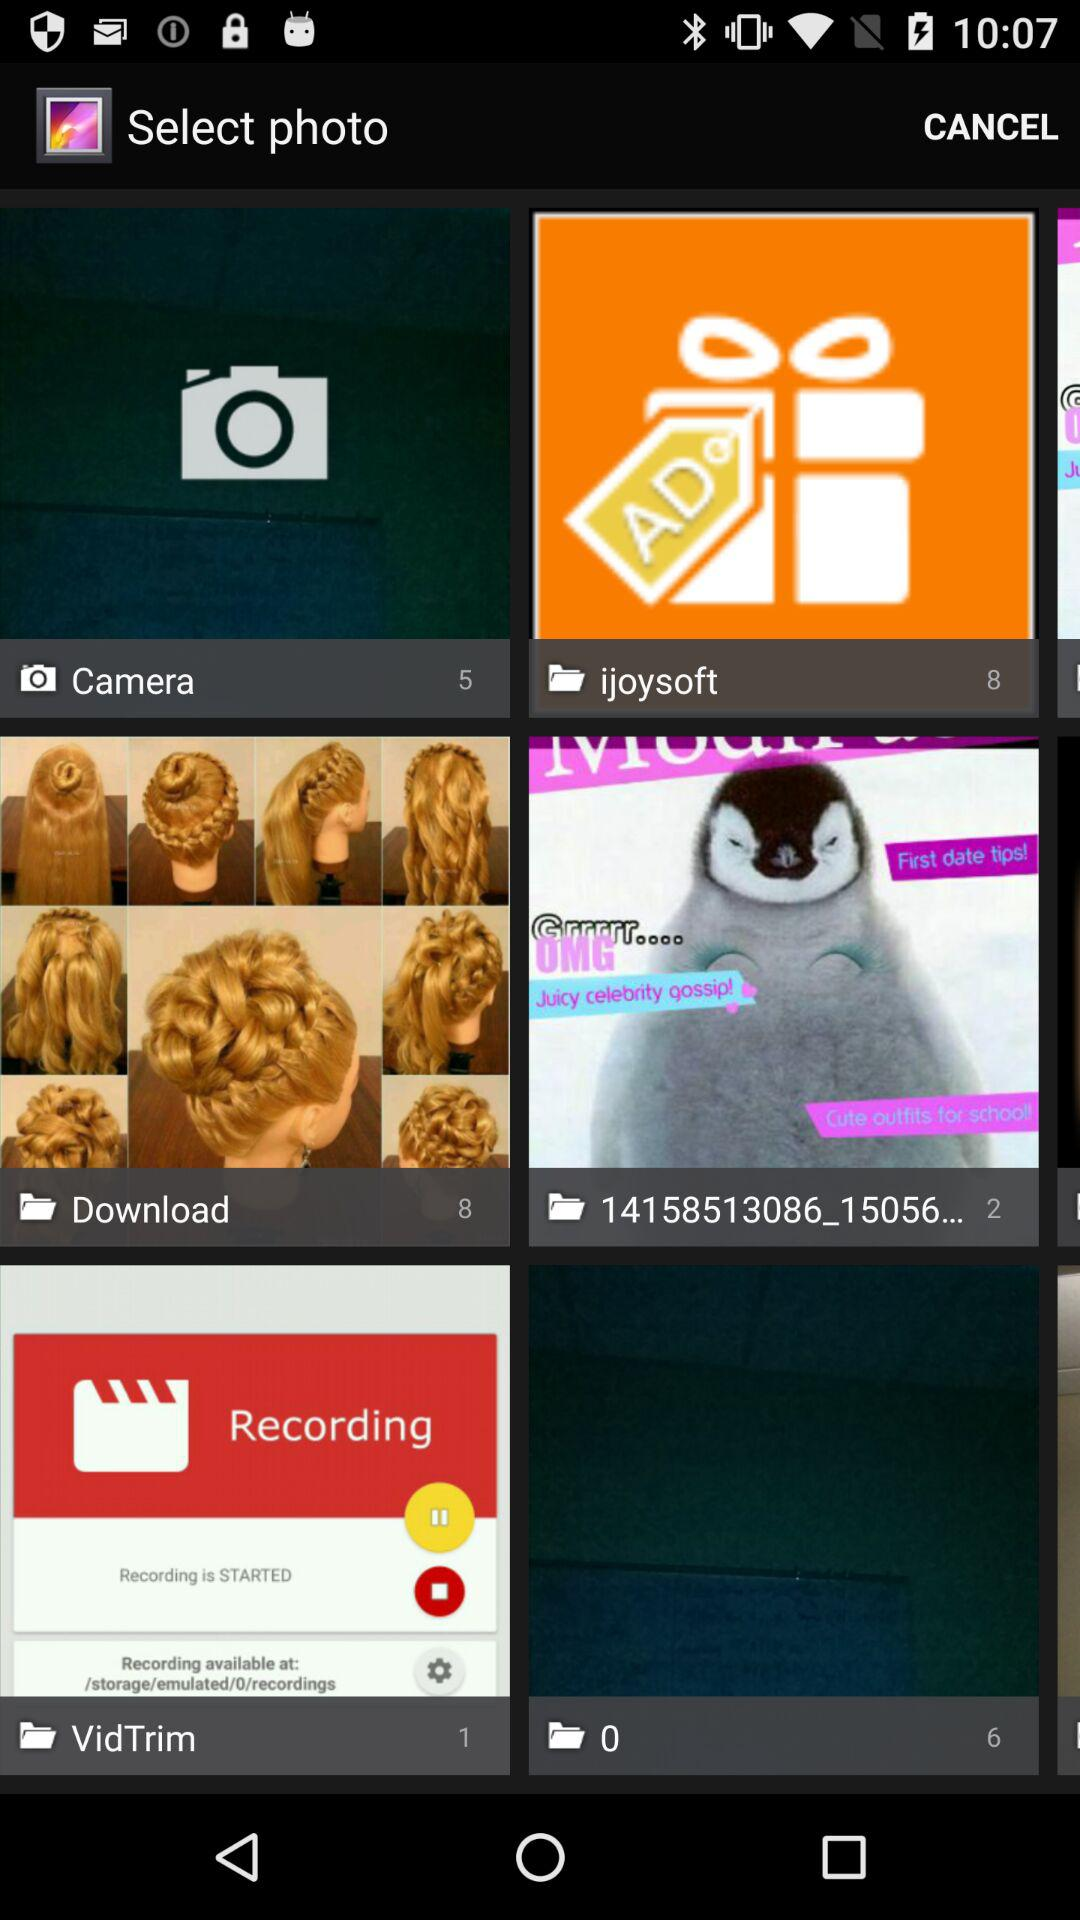How many photos are there in the "Download" folder? There are 8 photos in the "Download" folder. 